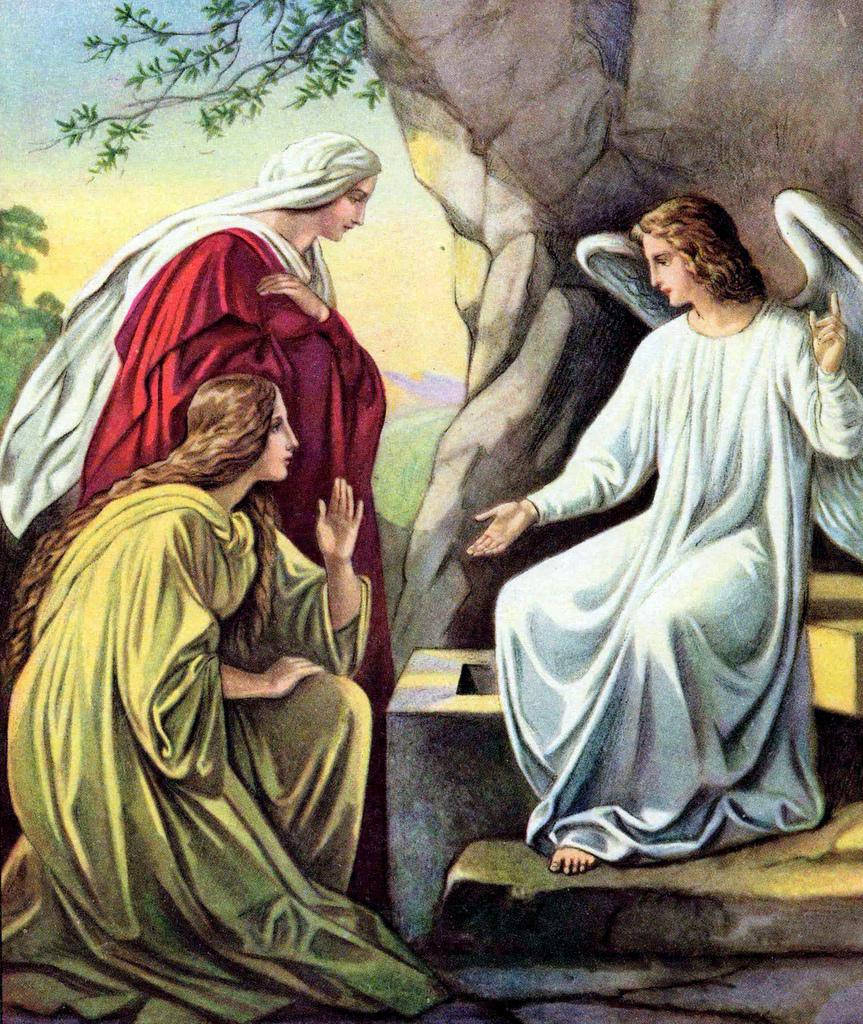What is the main subject of the image? There is a painting in the image. What is depicted in the painting? The painting features a goddess sitting on a wall. Are there any other figures in the painting? Yes, there are two devotees in front of the goddess. What can be seen in the background of the painting? There is a tree in the background of the painting. Where is the cushion placed in the image? There is no cushion present in the image. Can you see a truck in the background of the painting? No, there is no truck visible in the painting; it only features a tree in the background. 